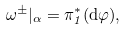Convert formula to latex. <formula><loc_0><loc_0><loc_500><loc_500>\omega ^ { \pm } | _ { \alpha } = \pi _ { 1 } ^ { * } ( \mathrm d \varphi ) ,</formula> 